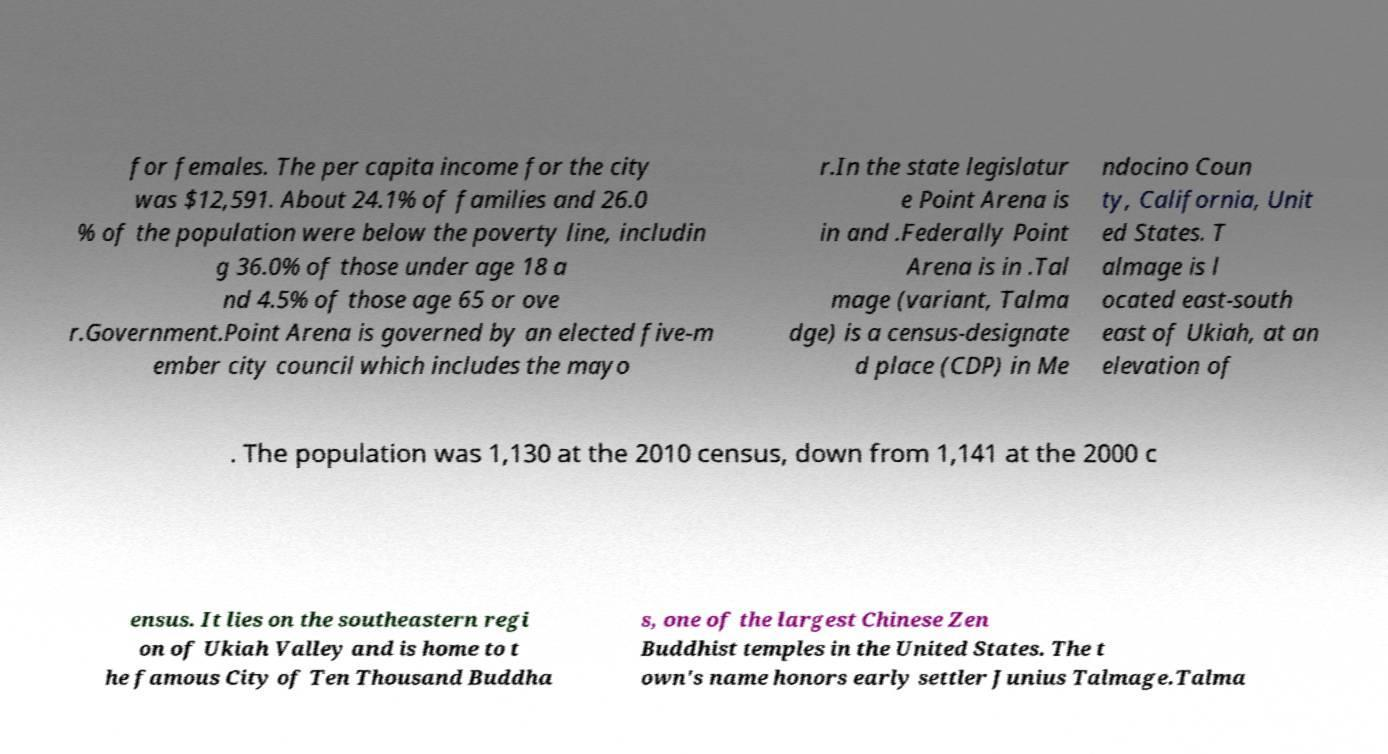Could you extract and type out the text from this image? for females. The per capita income for the city was $12,591. About 24.1% of families and 26.0 % of the population were below the poverty line, includin g 36.0% of those under age 18 a nd 4.5% of those age 65 or ove r.Government.Point Arena is governed by an elected five-m ember city council which includes the mayo r.In the state legislatur e Point Arena is in and .Federally Point Arena is in .Tal mage (variant, Talma dge) is a census-designate d place (CDP) in Me ndocino Coun ty, California, Unit ed States. T almage is l ocated east-south east of Ukiah, at an elevation of . The population was 1,130 at the 2010 census, down from 1,141 at the 2000 c ensus. It lies on the southeastern regi on of Ukiah Valley and is home to t he famous City of Ten Thousand Buddha s, one of the largest Chinese Zen Buddhist temples in the United States. The t own's name honors early settler Junius Talmage.Talma 